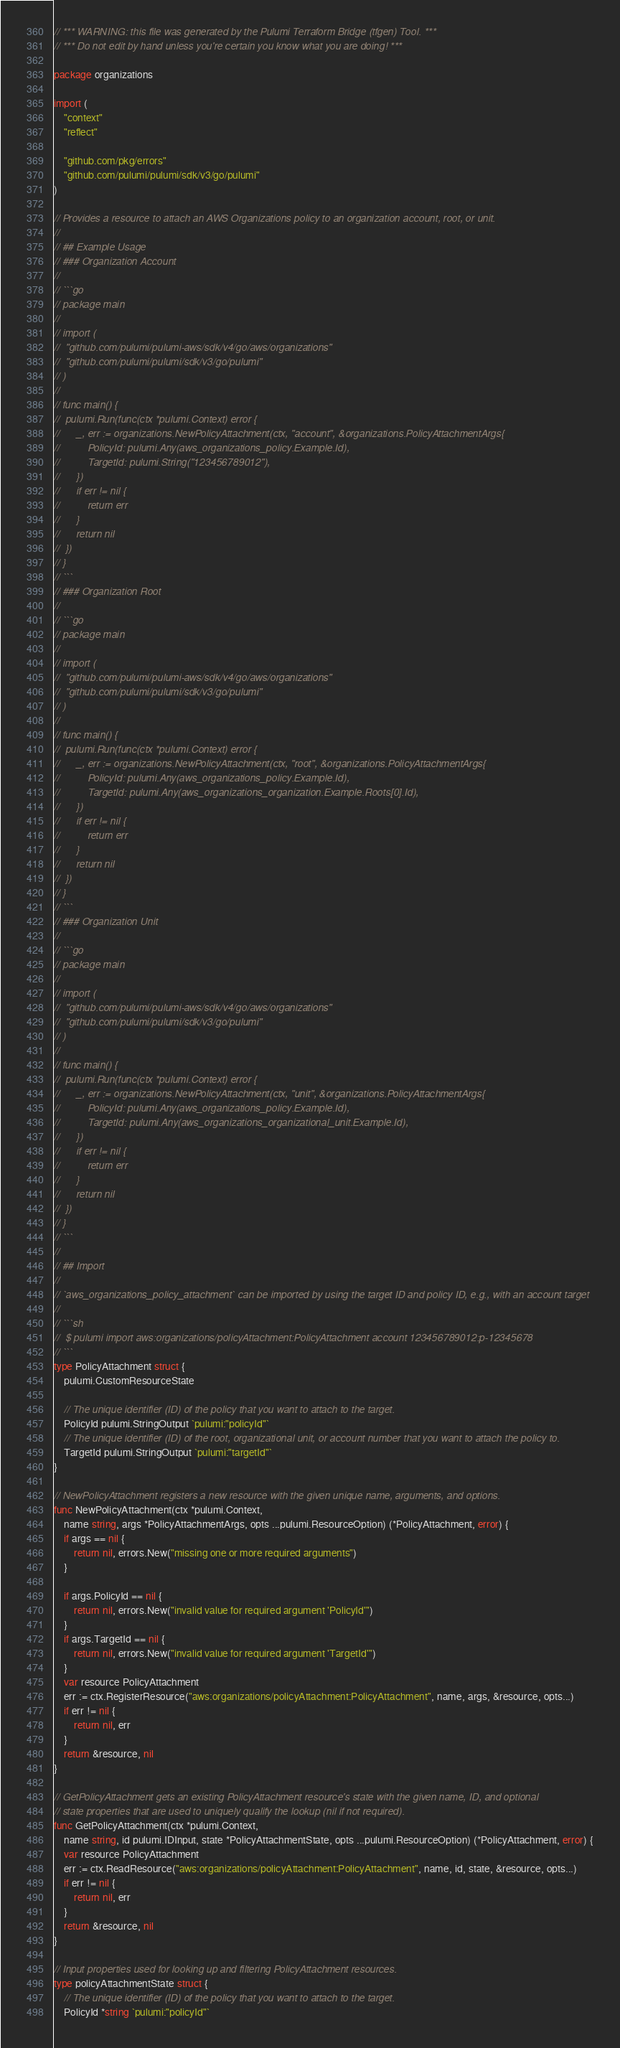<code> <loc_0><loc_0><loc_500><loc_500><_Go_>// *** WARNING: this file was generated by the Pulumi Terraform Bridge (tfgen) Tool. ***
// *** Do not edit by hand unless you're certain you know what you are doing! ***

package organizations

import (
	"context"
	"reflect"

	"github.com/pkg/errors"
	"github.com/pulumi/pulumi/sdk/v3/go/pulumi"
)

// Provides a resource to attach an AWS Organizations policy to an organization account, root, or unit.
//
// ## Example Usage
// ### Organization Account
//
// ```go
// package main
//
// import (
// 	"github.com/pulumi/pulumi-aws/sdk/v4/go/aws/organizations"
// 	"github.com/pulumi/pulumi/sdk/v3/go/pulumi"
// )
//
// func main() {
// 	pulumi.Run(func(ctx *pulumi.Context) error {
// 		_, err := organizations.NewPolicyAttachment(ctx, "account", &organizations.PolicyAttachmentArgs{
// 			PolicyId: pulumi.Any(aws_organizations_policy.Example.Id),
// 			TargetId: pulumi.String("123456789012"),
// 		})
// 		if err != nil {
// 			return err
// 		}
// 		return nil
// 	})
// }
// ```
// ### Organization Root
//
// ```go
// package main
//
// import (
// 	"github.com/pulumi/pulumi-aws/sdk/v4/go/aws/organizations"
// 	"github.com/pulumi/pulumi/sdk/v3/go/pulumi"
// )
//
// func main() {
// 	pulumi.Run(func(ctx *pulumi.Context) error {
// 		_, err := organizations.NewPolicyAttachment(ctx, "root", &organizations.PolicyAttachmentArgs{
// 			PolicyId: pulumi.Any(aws_organizations_policy.Example.Id),
// 			TargetId: pulumi.Any(aws_organizations_organization.Example.Roots[0].Id),
// 		})
// 		if err != nil {
// 			return err
// 		}
// 		return nil
// 	})
// }
// ```
// ### Organization Unit
//
// ```go
// package main
//
// import (
// 	"github.com/pulumi/pulumi-aws/sdk/v4/go/aws/organizations"
// 	"github.com/pulumi/pulumi/sdk/v3/go/pulumi"
// )
//
// func main() {
// 	pulumi.Run(func(ctx *pulumi.Context) error {
// 		_, err := organizations.NewPolicyAttachment(ctx, "unit", &organizations.PolicyAttachmentArgs{
// 			PolicyId: pulumi.Any(aws_organizations_policy.Example.Id),
// 			TargetId: pulumi.Any(aws_organizations_organizational_unit.Example.Id),
// 		})
// 		if err != nil {
// 			return err
// 		}
// 		return nil
// 	})
// }
// ```
//
// ## Import
//
// `aws_organizations_policy_attachment` can be imported by using the target ID and policy ID, e.g., with an account target
//
// ```sh
//  $ pulumi import aws:organizations/policyAttachment:PolicyAttachment account 123456789012:p-12345678
// ```
type PolicyAttachment struct {
	pulumi.CustomResourceState

	// The unique identifier (ID) of the policy that you want to attach to the target.
	PolicyId pulumi.StringOutput `pulumi:"policyId"`
	// The unique identifier (ID) of the root, organizational unit, or account number that you want to attach the policy to.
	TargetId pulumi.StringOutput `pulumi:"targetId"`
}

// NewPolicyAttachment registers a new resource with the given unique name, arguments, and options.
func NewPolicyAttachment(ctx *pulumi.Context,
	name string, args *PolicyAttachmentArgs, opts ...pulumi.ResourceOption) (*PolicyAttachment, error) {
	if args == nil {
		return nil, errors.New("missing one or more required arguments")
	}

	if args.PolicyId == nil {
		return nil, errors.New("invalid value for required argument 'PolicyId'")
	}
	if args.TargetId == nil {
		return nil, errors.New("invalid value for required argument 'TargetId'")
	}
	var resource PolicyAttachment
	err := ctx.RegisterResource("aws:organizations/policyAttachment:PolicyAttachment", name, args, &resource, opts...)
	if err != nil {
		return nil, err
	}
	return &resource, nil
}

// GetPolicyAttachment gets an existing PolicyAttachment resource's state with the given name, ID, and optional
// state properties that are used to uniquely qualify the lookup (nil if not required).
func GetPolicyAttachment(ctx *pulumi.Context,
	name string, id pulumi.IDInput, state *PolicyAttachmentState, opts ...pulumi.ResourceOption) (*PolicyAttachment, error) {
	var resource PolicyAttachment
	err := ctx.ReadResource("aws:organizations/policyAttachment:PolicyAttachment", name, id, state, &resource, opts...)
	if err != nil {
		return nil, err
	}
	return &resource, nil
}

// Input properties used for looking up and filtering PolicyAttachment resources.
type policyAttachmentState struct {
	// The unique identifier (ID) of the policy that you want to attach to the target.
	PolicyId *string `pulumi:"policyId"`</code> 